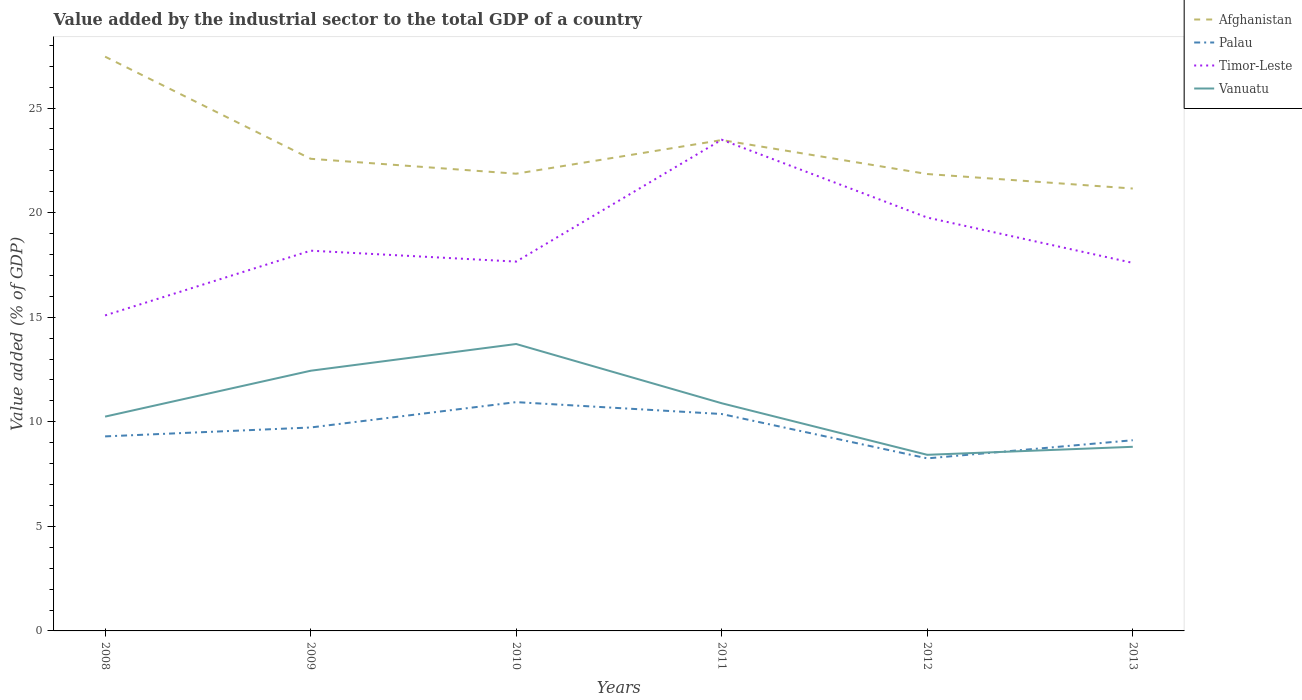Is the number of lines equal to the number of legend labels?
Offer a terse response. Yes. Across all years, what is the maximum value added by the industrial sector to the total GDP in Timor-Leste?
Offer a very short reply. 15.09. What is the total value added by the industrial sector to the total GDP in Palau in the graph?
Your answer should be very brief. 1.48. What is the difference between the highest and the second highest value added by the industrial sector to the total GDP in Afghanistan?
Your answer should be compact. 6.31. What is the difference between the highest and the lowest value added by the industrial sector to the total GDP in Afghanistan?
Your answer should be compact. 2. How many lines are there?
Give a very brief answer. 4. How many years are there in the graph?
Provide a succinct answer. 6. What is the difference between two consecutive major ticks on the Y-axis?
Provide a short and direct response. 5. Are the values on the major ticks of Y-axis written in scientific E-notation?
Your answer should be compact. No. Does the graph contain any zero values?
Offer a terse response. No. Does the graph contain grids?
Keep it short and to the point. No. Where does the legend appear in the graph?
Provide a short and direct response. Top right. How many legend labels are there?
Your answer should be compact. 4. How are the legend labels stacked?
Your response must be concise. Vertical. What is the title of the graph?
Your response must be concise. Value added by the industrial sector to the total GDP of a country. What is the label or title of the X-axis?
Offer a very short reply. Years. What is the label or title of the Y-axis?
Your answer should be very brief. Value added (% of GDP). What is the Value added (% of GDP) of Afghanistan in 2008?
Your response must be concise. 27.46. What is the Value added (% of GDP) of Palau in 2008?
Provide a succinct answer. 9.3. What is the Value added (% of GDP) in Timor-Leste in 2008?
Your answer should be compact. 15.09. What is the Value added (% of GDP) in Vanuatu in 2008?
Provide a short and direct response. 10.25. What is the Value added (% of GDP) in Afghanistan in 2009?
Your response must be concise. 22.58. What is the Value added (% of GDP) in Palau in 2009?
Ensure brevity in your answer.  9.73. What is the Value added (% of GDP) of Timor-Leste in 2009?
Make the answer very short. 18.18. What is the Value added (% of GDP) in Vanuatu in 2009?
Offer a terse response. 12.44. What is the Value added (% of GDP) of Afghanistan in 2010?
Make the answer very short. 21.86. What is the Value added (% of GDP) of Palau in 2010?
Ensure brevity in your answer.  10.94. What is the Value added (% of GDP) in Timor-Leste in 2010?
Your answer should be very brief. 17.66. What is the Value added (% of GDP) in Vanuatu in 2010?
Make the answer very short. 13.72. What is the Value added (% of GDP) in Afghanistan in 2011?
Your response must be concise. 23.47. What is the Value added (% of GDP) in Palau in 2011?
Provide a short and direct response. 10.37. What is the Value added (% of GDP) in Timor-Leste in 2011?
Your answer should be very brief. 23.49. What is the Value added (% of GDP) of Vanuatu in 2011?
Your answer should be very brief. 10.89. What is the Value added (% of GDP) in Afghanistan in 2012?
Your answer should be compact. 21.85. What is the Value added (% of GDP) in Palau in 2012?
Provide a short and direct response. 8.25. What is the Value added (% of GDP) of Timor-Leste in 2012?
Offer a terse response. 19.77. What is the Value added (% of GDP) in Vanuatu in 2012?
Your answer should be very brief. 8.42. What is the Value added (% of GDP) of Afghanistan in 2013?
Provide a short and direct response. 21.15. What is the Value added (% of GDP) in Palau in 2013?
Offer a very short reply. 9.12. What is the Value added (% of GDP) in Timor-Leste in 2013?
Keep it short and to the point. 17.6. What is the Value added (% of GDP) of Vanuatu in 2013?
Your response must be concise. 8.8. Across all years, what is the maximum Value added (% of GDP) of Afghanistan?
Offer a very short reply. 27.46. Across all years, what is the maximum Value added (% of GDP) of Palau?
Offer a terse response. 10.94. Across all years, what is the maximum Value added (% of GDP) of Timor-Leste?
Provide a short and direct response. 23.49. Across all years, what is the maximum Value added (% of GDP) of Vanuatu?
Your answer should be very brief. 13.72. Across all years, what is the minimum Value added (% of GDP) in Afghanistan?
Provide a succinct answer. 21.15. Across all years, what is the minimum Value added (% of GDP) in Palau?
Give a very brief answer. 8.25. Across all years, what is the minimum Value added (% of GDP) of Timor-Leste?
Make the answer very short. 15.09. Across all years, what is the minimum Value added (% of GDP) of Vanuatu?
Your answer should be very brief. 8.42. What is the total Value added (% of GDP) of Afghanistan in the graph?
Offer a terse response. 138.37. What is the total Value added (% of GDP) in Palau in the graph?
Your response must be concise. 57.71. What is the total Value added (% of GDP) in Timor-Leste in the graph?
Make the answer very short. 111.78. What is the total Value added (% of GDP) of Vanuatu in the graph?
Offer a terse response. 64.52. What is the difference between the Value added (% of GDP) in Afghanistan in 2008 and that in 2009?
Offer a very short reply. 4.88. What is the difference between the Value added (% of GDP) of Palau in 2008 and that in 2009?
Make the answer very short. -0.43. What is the difference between the Value added (% of GDP) of Timor-Leste in 2008 and that in 2009?
Make the answer very short. -3.1. What is the difference between the Value added (% of GDP) of Vanuatu in 2008 and that in 2009?
Provide a succinct answer. -2.19. What is the difference between the Value added (% of GDP) of Afghanistan in 2008 and that in 2010?
Give a very brief answer. 5.6. What is the difference between the Value added (% of GDP) in Palau in 2008 and that in 2010?
Make the answer very short. -1.64. What is the difference between the Value added (% of GDP) of Timor-Leste in 2008 and that in 2010?
Offer a very short reply. -2.57. What is the difference between the Value added (% of GDP) of Vanuatu in 2008 and that in 2010?
Provide a succinct answer. -3.47. What is the difference between the Value added (% of GDP) of Afghanistan in 2008 and that in 2011?
Keep it short and to the point. 3.99. What is the difference between the Value added (% of GDP) of Palau in 2008 and that in 2011?
Your response must be concise. -1.07. What is the difference between the Value added (% of GDP) in Timor-Leste in 2008 and that in 2011?
Your answer should be very brief. -8.4. What is the difference between the Value added (% of GDP) of Vanuatu in 2008 and that in 2011?
Provide a short and direct response. -0.64. What is the difference between the Value added (% of GDP) in Afghanistan in 2008 and that in 2012?
Your response must be concise. 5.61. What is the difference between the Value added (% of GDP) of Palau in 2008 and that in 2012?
Provide a short and direct response. 1.05. What is the difference between the Value added (% of GDP) in Timor-Leste in 2008 and that in 2012?
Make the answer very short. -4.68. What is the difference between the Value added (% of GDP) of Vanuatu in 2008 and that in 2012?
Ensure brevity in your answer.  1.83. What is the difference between the Value added (% of GDP) in Afghanistan in 2008 and that in 2013?
Your answer should be very brief. 6.31. What is the difference between the Value added (% of GDP) in Palau in 2008 and that in 2013?
Provide a succinct answer. 0.18. What is the difference between the Value added (% of GDP) in Timor-Leste in 2008 and that in 2013?
Your answer should be compact. -2.51. What is the difference between the Value added (% of GDP) of Vanuatu in 2008 and that in 2013?
Your answer should be very brief. 1.44. What is the difference between the Value added (% of GDP) in Afghanistan in 2009 and that in 2010?
Provide a succinct answer. 0.71. What is the difference between the Value added (% of GDP) in Palau in 2009 and that in 2010?
Offer a very short reply. -1.21. What is the difference between the Value added (% of GDP) of Timor-Leste in 2009 and that in 2010?
Offer a terse response. 0.52. What is the difference between the Value added (% of GDP) in Vanuatu in 2009 and that in 2010?
Ensure brevity in your answer.  -1.28. What is the difference between the Value added (% of GDP) in Afghanistan in 2009 and that in 2011?
Offer a terse response. -0.9. What is the difference between the Value added (% of GDP) in Palau in 2009 and that in 2011?
Offer a very short reply. -0.64. What is the difference between the Value added (% of GDP) of Timor-Leste in 2009 and that in 2011?
Offer a terse response. -5.31. What is the difference between the Value added (% of GDP) in Vanuatu in 2009 and that in 2011?
Your response must be concise. 1.55. What is the difference between the Value added (% of GDP) in Afghanistan in 2009 and that in 2012?
Offer a terse response. 0.73. What is the difference between the Value added (% of GDP) in Palau in 2009 and that in 2012?
Your response must be concise. 1.48. What is the difference between the Value added (% of GDP) in Timor-Leste in 2009 and that in 2012?
Ensure brevity in your answer.  -1.58. What is the difference between the Value added (% of GDP) of Vanuatu in 2009 and that in 2012?
Your answer should be compact. 4.02. What is the difference between the Value added (% of GDP) of Afghanistan in 2009 and that in 2013?
Your answer should be compact. 1.42. What is the difference between the Value added (% of GDP) of Palau in 2009 and that in 2013?
Your answer should be compact. 0.61. What is the difference between the Value added (% of GDP) of Timor-Leste in 2009 and that in 2013?
Make the answer very short. 0.58. What is the difference between the Value added (% of GDP) in Vanuatu in 2009 and that in 2013?
Your answer should be compact. 3.64. What is the difference between the Value added (% of GDP) of Afghanistan in 2010 and that in 2011?
Make the answer very short. -1.61. What is the difference between the Value added (% of GDP) in Palau in 2010 and that in 2011?
Ensure brevity in your answer.  0.57. What is the difference between the Value added (% of GDP) of Timor-Leste in 2010 and that in 2011?
Give a very brief answer. -5.83. What is the difference between the Value added (% of GDP) in Vanuatu in 2010 and that in 2011?
Provide a succinct answer. 2.83. What is the difference between the Value added (% of GDP) of Afghanistan in 2010 and that in 2012?
Your response must be concise. 0.01. What is the difference between the Value added (% of GDP) of Palau in 2010 and that in 2012?
Your answer should be compact. 2.69. What is the difference between the Value added (% of GDP) of Timor-Leste in 2010 and that in 2012?
Ensure brevity in your answer.  -2.11. What is the difference between the Value added (% of GDP) in Vanuatu in 2010 and that in 2012?
Your response must be concise. 5.3. What is the difference between the Value added (% of GDP) in Afghanistan in 2010 and that in 2013?
Provide a short and direct response. 0.71. What is the difference between the Value added (% of GDP) in Palau in 2010 and that in 2013?
Provide a succinct answer. 1.82. What is the difference between the Value added (% of GDP) of Timor-Leste in 2010 and that in 2013?
Ensure brevity in your answer.  0.06. What is the difference between the Value added (% of GDP) of Vanuatu in 2010 and that in 2013?
Offer a very short reply. 4.91. What is the difference between the Value added (% of GDP) of Afghanistan in 2011 and that in 2012?
Provide a short and direct response. 1.62. What is the difference between the Value added (% of GDP) of Palau in 2011 and that in 2012?
Make the answer very short. 2.12. What is the difference between the Value added (% of GDP) in Timor-Leste in 2011 and that in 2012?
Your answer should be very brief. 3.72. What is the difference between the Value added (% of GDP) in Vanuatu in 2011 and that in 2012?
Make the answer very short. 2.47. What is the difference between the Value added (% of GDP) in Afghanistan in 2011 and that in 2013?
Give a very brief answer. 2.32. What is the difference between the Value added (% of GDP) in Palau in 2011 and that in 2013?
Offer a terse response. 1.25. What is the difference between the Value added (% of GDP) of Timor-Leste in 2011 and that in 2013?
Your answer should be compact. 5.89. What is the difference between the Value added (% of GDP) of Vanuatu in 2011 and that in 2013?
Your answer should be very brief. 2.08. What is the difference between the Value added (% of GDP) in Afghanistan in 2012 and that in 2013?
Ensure brevity in your answer.  0.69. What is the difference between the Value added (% of GDP) in Palau in 2012 and that in 2013?
Keep it short and to the point. -0.87. What is the difference between the Value added (% of GDP) in Timor-Leste in 2012 and that in 2013?
Offer a very short reply. 2.17. What is the difference between the Value added (% of GDP) of Vanuatu in 2012 and that in 2013?
Provide a succinct answer. -0.38. What is the difference between the Value added (% of GDP) of Afghanistan in 2008 and the Value added (% of GDP) of Palau in 2009?
Your answer should be very brief. 17.73. What is the difference between the Value added (% of GDP) of Afghanistan in 2008 and the Value added (% of GDP) of Timor-Leste in 2009?
Your answer should be very brief. 9.28. What is the difference between the Value added (% of GDP) of Afghanistan in 2008 and the Value added (% of GDP) of Vanuatu in 2009?
Your answer should be compact. 15.02. What is the difference between the Value added (% of GDP) of Palau in 2008 and the Value added (% of GDP) of Timor-Leste in 2009?
Your answer should be compact. -8.88. What is the difference between the Value added (% of GDP) in Palau in 2008 and the Value added (% of GDP) in Vanuatu in 2009?
Make the answer very short. -3.14. What is the difference between the Value added (% of GDP) in Timor-Leste in 2008 and the Value added (% of GDP) in Vanuatu in 2009?
Provide a short and direct response. 2.65. What is the difference between the Value added (% of GDP) of Afghanistan in 2008 and the Value added (% of GDP) of Palau in 2010?
Provide a succinct answer. 16.52. What is the difference between the Value added (% of GDP) in Afghanistan in 2008 and the Value added (% of GDP) in Timor-Leste in 2010?
Make the answer very short. 9.8. What is the difference between the Value added (% of GDP) of Afghanistan in 2008 and the Value added (% of GDP) of Vanuatu in 2010?
Provide a short and direct response. 13.74. What is the difference between the Value added (% of GDP) of Palau in 2008 and the Value added (% of GDP) of Timor-Leste in 2010?
Ensure brevity in your answer.  -8.36. What is the difference between the Value added (% of GDP) of Palau in 2008 and the Value added (% of GDP) of Vanuatu in 2010?
Provide a succinct answer. -4.42. What is the difference between the Value added (% of GDP) of Timor-Leste in 2008 and the Value added (% of GDP) of Vanuatu in 2010?
Keep it short and to the point. 1.37. What is the difference between the Value added (% of GDP) of Afghanistan in 2008 and the Value added (% of GDP) of Palau in 2011?
Give a very brief answer. 17.09. What is the difference between the Value added (% of GDP) in Afghanistan in 2008 and the Value added (% of GDP) in Timor-Leste in 2011?
Your answer should be very brief. 3.97. What is the difference between the Value added (% of GDP) in Afghanistan in 2008 and the Value added (% of GDP) in Vanuatu in 2011?
Ensure brevity in your answer.  16.57. What is the difference between the Value added (% of GDP) of Palau in 2008 and the Value added (% of GDP) of Timor-Leste in 2011?
Your answer should be compact. -14.19. What is the difference between the Value added (% of GDP) of Palau in 2008 and the Value added (% of GDP) of Vanuatu in 2011?
Provide a short and direct response. -1.58. What is the difference between the Value added (% of GDP) of Timor-Leste in 2008 and the Value added (% of GDP) of Vanuatu in 2011?
Provide a short and direct response. 4.2. What is the difference between the Value added (% of GDP) in Afghanistan in 2008 and the Value added (% of GDP) in Palau in 2012?
Provide a succinct answer. 19.21. What is the difference between the Value added (% of GDP) of Afghanistan in 2008 and the Value added (% of GDP) of Timor-Leste in 2012?
Your response must be concise. 7.69. What is the difference between the Value added (% of GDP) of Afghanistan in 2008 and the Value added (% of GDP) of Vanuatu in 2012?
Your answer should be compact. 19.04. What is the difference between the Value added (% of GDP) of Palau in 2008 and the Value added (% of GDP) of Timor-Leste in 2012?
Your answer should be compact. -10.46. What is the difference between the Value added (% of GDP) of Palau in 2008 and the Value added (% of GDP) of Vanuatu in 2012?
Your answer should be very brief. 0.88. What is the difference between the Value added (% of GDP) of Timor-Leste in 2008 and the Value added (% of GDP) of Vanuatu in 2012?
Your answer should be very brief. 6.67. What is the difference between the Value added (% of GDP) of Afghanistan in 2008 and the Value added (% of GDP) of Palau in 2013?
Provide a succinct answer. 18.34. What is the difference between the Value added (% of GDP) in Afghanistan in 2008 and the Value added (% of GDP) in Timor-Leste in 2013?
Provide a short and direct response. 9.86. What is the difference between the Value added (% of GDP) of Afghanistan in 2008 and the Value added (% of GDP) of Vanuatu in 2013?
Offer a very short reply. 18.65. What is the difference between the Value added (% of GDP) of Palau in 2008 and the Value added (% of GDP) of Timor-Leste in 2013?
Offer a terse response. -8.3. What is the difference between the Value added (% of GDP) in Palau in 2008 and the Value added (% of GDP) in Vanuatu in 2013?
Provide a short and direct response. 0.5. What is the difference between the Value added (% of GDP) in Timor-Leste in 2008 and the Value added (% of GDP) in Vanuatu in 2013?
Give a very brief answer. 6.28. What is the difference between the Value added (% of GDP) of Afghanistan in 2009 and the Value added (% of GDP) of Palau in 2010?
Provide a short and direct response. 11.64. What is the difference between the Value added (% of GDP) of Afghanistan in 2009 and the Value added (% of GDP) of Timor-Leste in 2010?
Provide a succinct answer. 4.92. What is the difference between the Value added (% of GDP) of Afghanistan in 2009 and the Value added (% of GDP) of Vanuatu in 2010?
Provide a short and direct response. 8.86. What is the difference between the Value added (% of GDP) of Palau in 2009 and the Value added (% of GDP) of Timor-Leste in 2010?
Your answer should be very brief. -7.93. What is the difference between the Value added (% of GDP) of Palau in 2009 and the Value added (% of GDP) of Vanuatu in 2010?
Offer a terse response. -3.99. What is the difference between the Value added (% of GDP) in Timor-Leste in 2009 and the Value added (% of GDP) in Vanuatu in 2010?
Offer a terse response. 4.46. What is the difference between the Value added (% of GDP) of Afghanistan in 2009 and the Value added (% of GDP) of Palau in 2011?
Give a very brief answer. 12.2. What is the difference between the Value added (% of GDP) of Afghanistan in 2009 and the Value added (% of GDP) of Timor-Leste in 2011?
Your response must be concise. -0.91. What is the difference between the Value added (% of GDP) of Afghanistan in 2009 and the Value added (% of GDP) of Vanuatu in 2011?
Make the answer very short. 11.69. What is the difference between the Value added (% of GDP) of Palau in 2009 and the Value added (% of GDP) of Timor-Leste in 2011?
Keep it short and to the point. -13.76. What is the difference between the Value added (% of GDP) in Palau in 2009 and the Value added (% of GDP) in Vanuatu in 2011?
Offer a terse response. -1.16. What is the difference between the Value added (% of GDP) in Timor-Leste in 2009 and the Value added (% of GDP) in Vanuatu in 2011?
Your response must be concise. 7.3. What is the difference between the Value added (% of GDP) in Afghanistan in 2009 and the Value added (% of GDP) in Palau in 2012?
Your response must be concise. 14.33. What is the difference between the Value added (% of GDP) of Afghanistan in 2009 and the Value added (% of GDP) of Timor-Leste in 2012?
Keep it short and to the point. 2.81. What is the difference between the Value added (% of GDP) in Afghanistan in 2009 and the Value added (% of GDP) in Vanuatu in 2012?
Ensure brevity in your answer.  14.15. What is the difference between the Value added (% of GDP) of Palau in 2009 and the Value added (% of GDP) of Timor-Leste in 2012?
Offer a very short reply. -10.04. What is the difference between the Value added (% of GDP) of Palau in 2009 and the Value added (% of GDP) of Vanuatu in 2012?
Offer a very short reply. 1.31. What is the difference between the Value added (% of GDP) of Timor-Leste in 2009 and the Value added (% of GDP) of Vanuatu in 2012?
Ensure brevity in your answer.  9.76. What is the difference between the Value added (% of GDP) of Afghanistan in 2009 and the Value added (% of GDP) of Palau in 2013?
Your response must be concise. 13.46. What is the difference between the Value added (% of GDP) of Afghanistan in 2009 and the Value added (% of GDP) of Timor-Leste in 2013?
Your response must be concise. 4.98. What is the difference between the Value added (% of GDP) in Afghanistan in 2009 and the Value added (% of GDP) in Vanuatu in 2013?
Offer a very short reply. 13.77. What is the difference between the Value added (% of GDP) in Palau in 2009 and the Value added (% of GDP) in Timor-Leste in 2013?
Ensure brevity in your answer.  -7.87. What is the difference between the Value added (% of GDP) in Palau in 2009 and the Value added (% of GDP) in Vanuatu in 2013?
Keep it short and to the point. 0.92. What is the difference between the Value added (% of GDP) of Timor-Leste in 2009 and the Value added (% of GDP) of Vanuatu in 2013?
Provide a short and direct response. 9.38. What is the difference between the Value added (% of GDP) of Afghanistan in 2010 and the Value added (% of GDP) of Palau in 2011?
Keep it short and to the point. 11.49. What is the difference between the Value added (% of GDP) in Afghanistan in 2010 and the Value added (% of GDP) in Timor-Leste in 2011?
Provide a short and direct response. -1.62. What is the difference between the Value added (% of GDP) of Afghanistan in 2010 and the Value added (% of GDP) of Vanuatu in 2011?
Offer a terse response. 10.98. What is the difference between the Value added (% of GDP) of Palau in 2010 and the Value added (% of GDP) of Timor-Leste in 2011?
Provide a succinct answer. -12.55. What is the difference between the Value added (% of GDP) of Palau in 2010 and the Value added (% of GDP) of Vanuatu in 2011?
Keep it short and to the point. 0.05. What is the difference between the Value added (% of GDP) in Timor-Leste in 2010 and the Value added (% of GDP) in Vanuatu in 2011?
Keep it short and to the point. 6.77. What is the difference between the Value added (% of GDP) in Afghanistan in 2010 and the Value added (% of GDP) in Palau in 2012?
Offer a very short reply. 13.61. What is the difference between the Value added (% of GDP) in Afghanistan in 2010 and the Value added (% of GDP) in Timor-Leste in 2012?
Make the answer very short. 2.1. What is the difference between the Value added (% of GDP) in Afghanistan in 2010 and the Value added (% of GDP) in Vanuatu in 2012?
Offer a terse response. 13.44. What is the difference between the Value added (% of GDP) of Palau in 2010 and the Value added (% of GDP) of Timor-Leste in 2012?
Keep it short and to the point. -8.83. What is the difference between the Value added (% of GDP) of Palau in 2010 and the Value added (% of GDP) of Vanuatu in 2012?
Offer a very short reply. 2.52. What is the difference between the Value added (% of GDP) of Timor-Leste in 2010 and the Value added (% of GDP) of Vanuatu in 2012?
Offer a very short reply. 9.24. What is the difference between the Value added (% of GDP) in Afghanistan in 2010 and the Value added (% of GDP) in Palau in 2013?
Your answer should be very brief. 12.74. What is the difference between the Value added (% of GDP) in Afghanistan in 2010 and the Value added (% of GDP) in Timor-Leste in 2013?
Keep it short and to the point. 4.26. What is the difference between the Value added (% of GDP) in Afghanistan in 2010 and the Value added (% of GDP) in Vanuatu in 2013?
Your answer should be very brief. 13.06. What is the difference between the Value added (% of GDP) in Palau in 2010 and the Value added (% of GDP) in Timor-Leste in 2013?
Your response must be concise. -6.66. What is the difference between the Value added (% of GDP) of Palau in 2010 and the Value added (% of GDP) of Vanuatu in 2013?
Provide a succinct answer. 2.14. What is the difference between the Value added (% of GDP) in Timor-Leste in 2010 and the Value added (% of GDP) in Vanuatu in 2013?
Offer a very short reply. 8.86. What is the difference between the Value added (% of GDP) of Afghanistan in 2011 and the Value added (% of GDP) of Palau in 2012?
Make the answer very short. 15.22. What is the difference between the Value added (% of GDP) of Afghanistan in 2011 and the Value added (% of GDP) of Timor-Leste in 2012?
Ensure brevity in your answer.  3.71. What is the difference between the Value added (% of GDP) of Afghanistan in 2011 and the Value added (% of GDP) of Vanuatu in 2012?
Ensure brevity in your answer.  15.05. What is the difference between the Value added (% of GDP) of Palau in 2011 and the Value added (% of GDP) of Timor-Leste in 2012?
Make the answer very short. -9.39. What is the difference between the Value added (% of GDP) of Palau in 2011 and the Value added (% of GDP) of Vanuatu in 2012?
Offer a terse response. 1.95. What is the difference between the Value added (% of GDP) of Timor-Leste in 2011 and the Value added (% of GDP) of Vanuatu in 2012?
Make the answer very short. 15.07. What is the difference between the Value added (% of GDP) of Afghanistan in 2011 and the Value added (% of GDP) of Palau in 2013?
Your answer should be compact. 14.35. What is the difference between the Value added (% of GDP) of Afghanistan in 2011 and the Value added (% of GDP) of Timor-Leste in 2013?
Your answer should be compact. 5.87. What is the difference between the Value added (% of GDP) of Afghanistan in 2011 and the Value added (% of GDP) of Vanuatu in 2013?
Offer a terse response. 14.67. What is the difference between the Value added (% of GDP) in Palau in 2011 and the Value added (% of GDP) in Timor-Leste in 2013?
Provide a succinct answer. -7.23. What is the difference between the Value added (% of GDP) of Palau in 2011 and the Value added (% of GDP) of Vanuatu in 2013?
Keep it short and to the point. 1.57. What is the difference between the Value added (% of GDP) in Timor-Leste in 2011 and the Value added (% of GDP) in Vanuatu in 2013?
Keep it short and to the point. 14.68. What is the difference between the Value added (% of GDP) in Afghanistan in 2012 and the Value added (% of GDP) in Palau in 2013?
Offer a terse response. 12.73. What is the difference between the Value added (% of GDP) in Afghanistan in 2012 and the Value added (% of GDP) in Timor-Leste in 2013?
Keep it short and to the point. 4.25. What is the difference between the Value added (% of GDP) of Afghanistan in 2012 and the Value added (% of GDP) of Vanuatu in 2013?
Your answer should be very brief. 13.04. What is the difference between the Value added (% of GDP) in Palau in 2012 and the Value added (% of GDP) in Timor-Leste in 2013?
Give a very brief answer. -9.35. What is the difference between the Value added (% of GDP) in Palau in 2012 and the Value added (% of GDP) in Vanuatu in 2013?
Keep it short and to the point. -0.55. What is the difference between the Value added (% of GDP) in Timor-Leste in 2012 and the Value added (% of GDP) in Vanuatu in 2013?
Ensure brevity in your answer.  10.96. What is the average Value added (% of GDP) of Afghanistan per year?
Make the answer very short. 23.06. What is the average Value added (% of GDP) in Palau per year?
Your response must be concise. 9.62. What is the average Value added (% of GDP) in Timor-Leste per year?
Provide a short and direct response. 18.63. What is the average Value added (% of GDP) of Vanuatu per year?
Provide a short and direct response. 10.75. In the year 2008, what is the difference between the Value added (% of GDP) in Afghanistan and Value added (% of GDP) in Palau?
Make the answer very short. 18.16. In the year 2008, what is the difference between the Value added (% of GDP) of Afghanistan and Value added (% of GDP) of Timor-Leste?
Your answer should be very brief. 12.37. In the year 2008, what is the difference between the Value added (% of GDP) in Afghanistan and Value added (% of GDP) in Vanuatu?
Provide a succinct answer. 17.21. In the year 2008, what is the difference between the Value added (% of GDP) in Palau and Value added (% of GDP) in Timor-Leste?
Keep it short and to the point. -5.78. In the year 2008, what is the difference between the Value added (% of GDP) of Palau and Value added (% of GDP) of Vanuatu?
Ensure brevity in your answer.  -0.95. In the year 2008, what is the difference between the Value added (% of GDP) in Timor-Leste and Value added (% of GDP) in Vanuatu?
Ensure brevity in your answer.  4.84. In the year 2009, what is the difference between the Value added (% of GDP) in Afghanistan and Value added (% of GDP) in Palau?
Offer a very short reply. 12.85. In the year 2009, what is the difference between the Value added (% of GDP) of Afghanistan and Value added (% of GDP) of Timor-Leste?
Keep it short and to the point. 4.39. In the year 2009, what is the difference between the Value added (% of GDP) of Afghanistan and Value added (% of GDP) of Vanuatu?
Offer a terse response. 10.14. In the year 2009, what is the difference between the Value added (% of GDP) in Palau and Value added (% of GDP) in Timor-Leste?
Your response must be concise. -8.45. In the year 2009, what is the difference between the Value added (% of GDP) in Palau and Value added (% of GDP) in Vanuatu?
Ensure brevity in your answer.  -2.71. In the year 2009, what is the difference between the Value added (% of GDP) of Timor-Leste and Value added (% of GDP) of Vanuatu?
Make the answer very short. 5.74. In the year 2010, what is the difference between the Value added (% of GDP) in Afghanistan and Value added (% of GDP) in Palau?
Offer a terse response. 10.92. In the year 2010, what is the difference between the Value added (% of GDP) of Afghanistan and Value added (% of GDP) of Timor-Leste?
Ensure brevity in your answer.  4.2. In the year 2010, what is the difference between the Value added (% of GDP) in Afghanistan and Value added (% of GDP) in Vanuatu?
Offer a very short reply. 8.14. In the year 2010, what is the difference between the Value added (% of GDP) of Palau and Value added (% of GDP) of Timor-Leste?
Make the answer very short. -6.72. In the year 2010, what is the difference between the Value added (% of GDP) of Palau and Value added (% of GDP) of Vanuatu?
Provide a short and direct response. -2.78. In the year 2010, what is the difference between the Value added (% of GDP) of Timor-Leste and Value added (% of GDP) of Vanuatu?
Ensure brevity in your answer.  3.94. In the year 2011, what is the difference between the Value added (% of GDP) of Afghanistan and Value added (% of GDP) of Palau?
Offer a terse response. 13.1. In the year 2011, what is the difference between the Value added (% of GDP) in Afghanistan and Value added (% of GDP) in Timor-Leste?
Keep it short and to the point. -0.02. In the year 2011, what is the difference between the Value added (% of GDP) in Afghanistan and Value added (% of GDP) in Vanuatu?
Keep it short and to the point. 12.59. In the year 2011, what is the difference between the Value added (% of GDP) in Palau and Value added (% of GDP) in Timor-Leste?
Provide a short and direct response. -13.12. In the year 2011, what is the difference between the Value added (% of GDP) of Palau and Value added (% of GDP) of Vanuatu?
Your answer should be very brief. -0.51. In the year 2011, what is the difference between the Value added (% of GDP) in Timor-Leste and Value added (% of GDP) in Vanuatu?
Your answer should be compact. 12.6. In the year 2012, what is the difference between the Value added (% of GDP) in Afghanistan and Value added (% of GDP) in Palau?
Your answer should be compact. 13.6. In the year 2012, what is the difference between the Value added (% of GDP) of Afghanistan and Value added (% of GDP) of Timor-Leste?
Provide a succinct answer. 2.08. In the year 2012, what is the difference between the Value added (% of GDP) in Afghanistan and Value added (% of GDP) in Vanuatu?
Give a very brief answer. 13.43. In the year 2012, what is the difference between the Value added (% of GDP) in Palau and Value added (% of GDP) in Timor-Leste?
Make the answer very short. -11.52. In the year 2012, what is the difference between the Value added (% of GDP) in Palau and Value added (% of GDP) in Vanuatu?
Your answer should be compact. -0.17. In the year 2012, what is the difference between the Value added (% of GDP) of Timor-Leste and Value added (% of GDP) of Vanuatu?
Your answer should be very brief. 11.34. In the year 2013, what is the difference between the Value added (% of GDP) in Afghanistan and Value added (% of GDP) in Palau?
Keep it short and to the point. 12.04. In the year 2013, what is the difference between the Value added (% of GDP) in Afghanistan and Value added (% of GDP) in Timor-Leste?
Provide a succinct answer. 3.56. In the year 2013, what is the difference between the Value added (% of GDP) in Afghanistan and Value added (% of GDP) in Vanuatu?
Make the answer very short. 12.35. In the year 2013, what is the difference between the Value added (% of GDP) of Palau and Value added (% of GDP) of Timor-Leste?
Offer a very short reply. -8.48. In the year 2013, what is the difference between the Value added (% of GDP) in Palau and Value added (% of GDP) in Vanuatu?
Give a very brief answer. 0.31. In the year 2013, what is the difference between the Value added (% of GDP) in Timor-Leste and Value added (% of GDP) in Vanuatu?
Keep it short and to the point. 8.79. What is the ratio of the Value added (% of GDP) in Afghanistan in 2008 to that in 2009?
Offer a terse response. 1.22. What is the ratio of the Value added (% of GDP) of Palau in 2008 to that in 2009?
Offer a very short reply. 0.96. What is the ratio of the Value added (% of GDP) of Timor-Leste in 2008 to that in 2009?
Offer a very short reply. 0.83. What is the ratio of the Value added (% of GDP) of Vanuatu in 2008 to that in 2009?
Ensure brevity in your answer.  0.82. What is the ratio of the Value added (% of GDP) in Afghanistan in 2008 to that in 2010?
Your answer should be very brief. 1.26. What is the ratio of the Value added (% of GDP) in Palau in 2008 to that in 2010?
Your response must be concise. 0.85. What is the ratio of the Value added (% of GDP) in Timor-Leste in 2008 to that in 2010?
Provide a short and direct response. 0.85. What is the ratio of the Value added (% of GDP) of Vanuatu in 2008 to that in 2010?
Your answer should be compact. 0.75. What is the ratio of the Value added (% of GDP) of Afghanistan in 2008 to that in 2011?
Provide a short and direct response. 1.17. What is the ratio of the Value added (% of GDP) in Palau in 2008 to that in 2011?
Keep it short and to the point. 0.9. What is the ratio of the Value added (% of GDP) of Timor-Leste in 2008 to that in 2011?
Offer a terse response. 0.64. What is the ratio of the Value added (% of GDP) of Vanuatu in 2008 to that in 2011?
Your answer should be compact. 0.94. What is the ratio of the Value added (% of GDP) in Afghanistan in 2008 to that in 2012?
Your answer should be very brief. 1.26. What is the ratio of the Value added (% of GDP) of Palau in 2008 to that in 2012?
Offer a terse response. 1.13. What is the ratio of the Value added (% of GDP) in Timor-Leste in 2008 to that in 2012?
Provide a short and direct response. 0.76. What is the ratio of the Value added (% of GDP) in Vanuatu in 2008 to that in 2012?
Offer a terse response. 1.22. What is the ratio of the Value added (% of GDP) in Afghanistan in 2008 to that in 2013?
Your response must be concise. 1.3. What is the ratio of the Value added (% of GDP) in Palau in 2008 to that in 2013?
Your answer should be very brief. 1.02. What is the ratio of the Value added (% of GDP) of Timor-Leste in 2008 to that in 2013?
Make the answer very short. 0.86. What is the ratio of the Value added (% of GDP) of Vanuatu in 2008 to that in 2013?
Your answer should be very brief. 1.16. What is the ratio of the Value added (% of GDP) of Afghanistan in 2009 to that in 2010?
Ensure brevity in your answer.  1.03. What is the ratio of the Value added (% of GDP) of Palau in 2009 to that in 2010?
Make the answer very short. 0.89. What is the ratio of the Value added (% of GDP) of Timor-Leste in 2009 to that in 2010?
Provide a short and direct response. 1.03. What is the ratio of the Value added (% of GDP) in Vanuatu in 2009 to that in 2010?
Offer a terse response. 0.91. What is the ratio of the Value added (% of GDP) in Afghanistan in 2009 to that in 2011?
Give a very brief answer. 0.96. What is the ratio of the Value added (% of GDP) in Palau in 2009 to that in 2011?
Your answer should be very brief. 0.94. What is the ratio of the Value added (% of GDP) in Timor-Leste in 2009 to that in 2011?
Offer a very short reply. 0.77. What is the ratio of the Value added (% of GDP) of Vanuatu in 2009 to that in 2011?
Keep it short and to the point. 1.14. What is the ratio of the Value added (% of GDP) of Afghanistan in 2009 to that in 2012?
Provide a succinct answer. 1.03. What is the ratio of the Value added (% of GDP) in Palau in 2009 to that in 2012?
Your response must be concise. 1.18. What is the ratio of the Value added (% of GDP) of Timor-Leste in 2009 to that in 2012?
Keep it short and to the point. 0.92. What is the ratio of the Value added (% of GDP) of Vanuatu in 2009 to that in 2012?
Offer a terse response. 1.48. What is the ratio of the Value added (% of GDP) of Afghanistan in 2009 to that in 2013?
Your answer should be very brief. 1.07. What is the ratio of the Value added (% of GDP) in Palau in 2009 to that in 2013?
Your answer should be very brief. 1.07. What is the ratio of the Value added (% of GDP) of Timor-Leste in 2009 to that in 2013?
Your answer should be very brief. 1.03. What is the ratio of the Value added (% of GDP) of Vanuatu in 2009 to that in 2013?
Offer a very short reply. 1.41. What is the ratio of the Value added (% of GDP) in Afghanistan in 2010 to that in 2011?
Make the answer very short. 0.93. What is the ratio of the Value added (% of GDP) of Palau in 2010 to that in 2011?
Give a very brief answer. 1.05. What is the ratio of the Value added (% of GDP) in Timor-Leste in 2010 to that in 2011?
Your answer should be very brief. 0.75. What is the ratio of the Value added (% of GDP) of Vanuatu in 2010 to that in 2011?
Give a very brief answer. 1.26. What is the ratio of the Value added (% of GDP) in Palau in 2010 to that in 2012?
Keep it short and to the point. 1.33. What is the ratio of the Value added (% of GDP) of Timor-Leste in 2010 to that in 2012?
Make the answer very short. 0.89. What is the ratio of the Value added (% of GDP) of Vanuatu in 2010 to that in 2012?
Provide a short and direct response. 1.63. What is the ratio of the Value added (% of GDP) in Afghanistan in 2010 to that in 2013?
Your answer should be compact. 1.03. What is the ratio of the Value added (% of GDP) of Palau in 2010 to that in 2013?
Offer a terse response. 1.2. What is the ratio of the Value added (% of GDP) in Timor-Leste in 2010 to that in 2013?
Give a very brief answer. 1. What is the ratio of the Value added (% of GDP) in Vanuatu in 2010 to that in 2013?
Your answer should be very brief. 1.56. What is the ratio of the Value added (% of GDP) in Afghanistan in 2011 to that in 2012?
Keep it short and to the point. 1.07. What is the ratio of the Value added (% of GDP) of Palau in 2011 to that in 2012?
Keep it short and to the point. 1.26. What is the ratio of the Value added (% of GDP) in Timor-Leste in 2011 to that in 2012?
Ensure brevity in your answer.  1.19. What is the ratio of the Value added (% of GDP) of Vanuatu in 2011 to that in 2012?
Keep it short and to the point. 1.29. What is the ratio of the Value added (% of GDP) in Afghanistan in 2011 to that in 2013?
Your answer should be compact. 1.11. What is the ratio of the Value added (% of GDP) in Palau in 2011 to that in 2013?
Your answer should be very brief. 1.14. What is the ratio of the Value added (% of GDP) in Timor-Leste in 2011 to that in 2013?
Give a very brief answer. 1.33. What is the ratio of the Value added (% of GDP) of Vanuatu in 2011 to that in 2013?
Offer a terse response. 1.24. What is the ratio of the Value added (% of GDP) in Afghanistan in 2012 to that in 2013?
Provide a short and direct response. 1.03. What is the ratio of the Value added (% of GDP) in Palau in 2012 to that in 2013?
Offer a terse response. 0.9. What is the ratio of the Value added (% of GDP) in Timor-Leste in 2012 to that in 2013?
Offer a terse response. 1.12. What is the ratio of the Value added (% of GDP) of Vanuatu in 2012 to that in 2013?
Your answer should be very brief. 0.96. What is the difference between the highest and the second highest Value added (% of GDP) of Afghanistan?
Offer a very short reply. 3.99. What is the difference between the highest and the second highest Value added (% of GDP) in Palau?
Ensure brevity in your answer.  0.57. What is the difference between the highest and the second highest Value added (% of GDP) of Timor-Leste?
Give a very brief answer. 3.72. What is the difference between the highest and the second highest Value added (% of GDP) in Vanuatu?
Your response must be concise. 1.28. What is the difference between the highest and the lowest Value added (% of GDP) of Afghanistan?
Give a very brief answer. 6.31. What is the difference between the highest and the lowest Value added (% of GDP) of Palau?
Provide a succinct answer. 2.69. What is the difference between the highest and the lowest Value added (% of GDP) in Timor-Leste?
Ensure brevity in your answer.  8.4. What is the difference between the highest and the lowest Value added (% of GDP) of Vanuatu?
Your answer should be very brief. 5.3. 